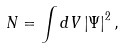Convert formula to latex. <formula><loc_0><loc_0><loc_500><loc_500>N = \int d V \left | \Psi \right | ^ { 2 } ,</formula> 